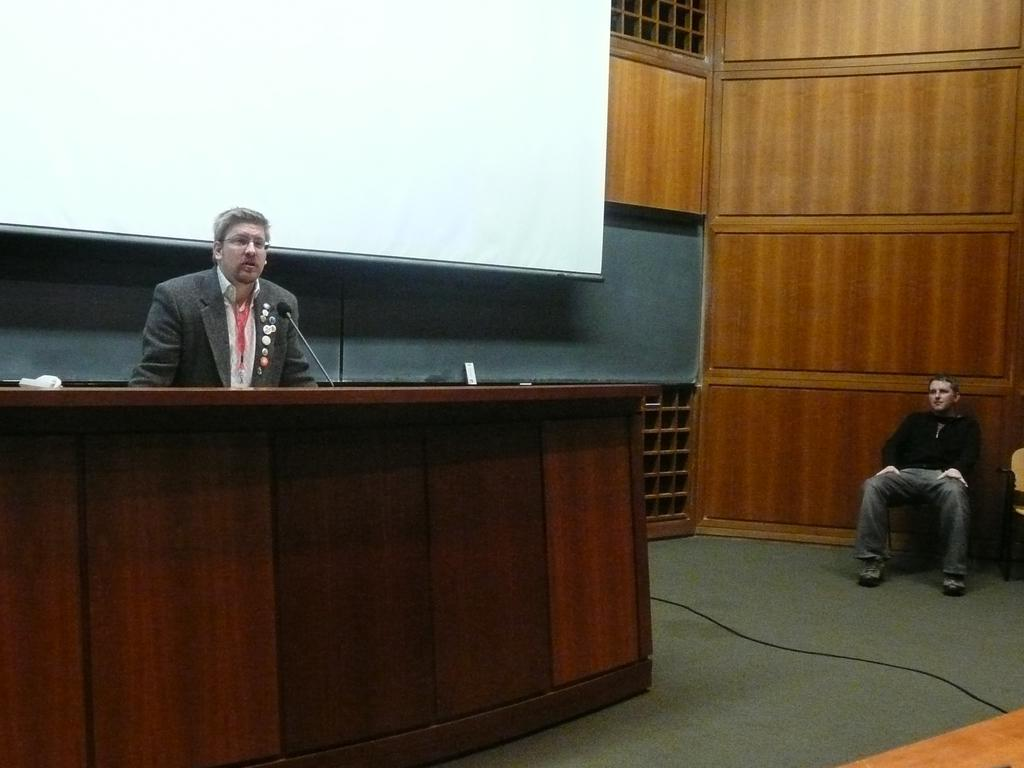What is the man in the image doing? The man is talking on a microphone in the image. What is the man wearing? The man is wearing a suit in the image. What can be seen behind the man? There is a screen behind the man in the image. What type of setting is suggested by the image? The setting appears to be a court or meeting area in the image. Can you describe the position of the other man in the image? There is a man sitting on the right side of the image. What type of pest can be seen crawling on the beds in the image? There are no beds present in the image, and therefore no pests can be observed. 